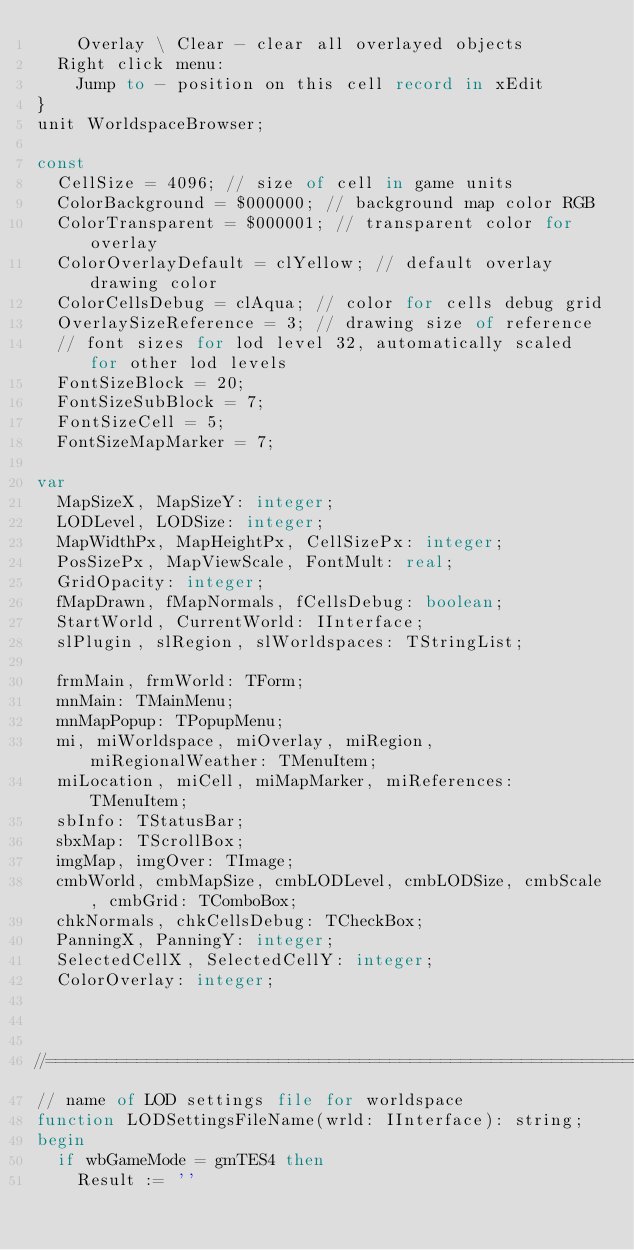<code> <loc_0><loc_0><loc_500><loc_500><_Pascal_>    Overlay \ Clear - clear all overlayed objects
  Right click menu:
    Jump to - position on this cell record in xEdit
}
unit WorldspaceBrowser;

const
  CellSize = 4096; // size of cell in game units
  ColorBackground = $000000; // background map color RGB
  ColorTransparent = $000001; // transparent color for overlay
  ColorOverlayDefault = clYellow; // default overlay drawing color
  ColorCellsDebug = clAqua; // color for cells debug grid
  OverlaySizeReference = 3; // drawing size of reference
  // font sizes for lod level 32, automatically scaled for other lod levels
  FontSizeBlock = 20;
  FontSizeSubBlock = 7;
  FontSizeCell = 5;
  FontSizeMapMarker = 7;

var
  MapSizeX, MapSizeY: integer;
  LODLevel, LODSize: integer;
  MapWidthPx, MapHeightPx, CellSizePx: integer;
  PosSizePx, MapViewScale, FontMult: real;
  GridOpacity: integer;
  fMapDrawn, fMapNormals, fCellsDebug: boolean;
  StartWorld, CurrentWorld: IInterface;
  slPlugin, slRegion, slWorldspaces: TStringList;

  frmMain, frmWorld: TForm;
  mnMain: TMainMenu;
  mnMapPopup: TPopupMenu;
  mi, miWorldspace, miOverlay, miRegion, miRegionalWeather: TMenuItem;
  miLocation, miCell, miMapMarker, miReferences: TMenuItem;
  sbInfo: TStatusBar;
  sbxMap: TScrollBox;
  imgMap, imgOver: TImage;
  cmbWorld, cmbMapSize, cmbLODLevel, cmbLODSize, cmbScale, cmbGrid: TComboBox;
  chkNormals, chkCellsDebug: TCheckBox;
  PanningX, PanningY: integer;
  SelectedCellX, SelectedCellY: integer;
  ColorOverlay: integer;


  
//============================================================================
// name of LOD settings file for worldspace
function LODSettingsFileName(wrld: IInterface): string;
begin
  if wbGameMode = gmTES4 then
    Result := ''</code> 